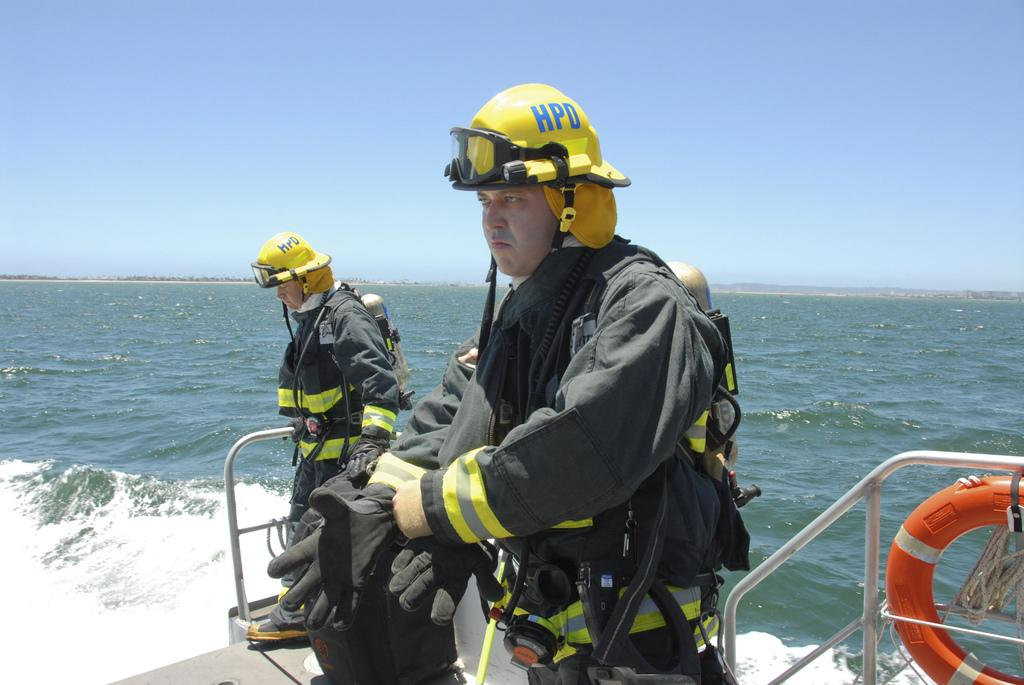How many men are in the image? There are two men in the image. What type of clothing are the men wearing on their upper bodies? The men are wearing jackets. What type of hand protection are the men wearing? The men are wearing gloves. What type of head protection are the men wearing? The men are wearing helmets. Where are the men standing in the image? The men are standing on a boat. What is present in the water near the boat? There is a swim tube in the image. What is the boat's location in relation to the water? The boat is on water. What can be seen in the background of the image? The sky is visible in the background of the image. What type of yam is being used as a flotation device in the image? There is no yam present in the image, and therefore no such object is being used as a flotation device. 